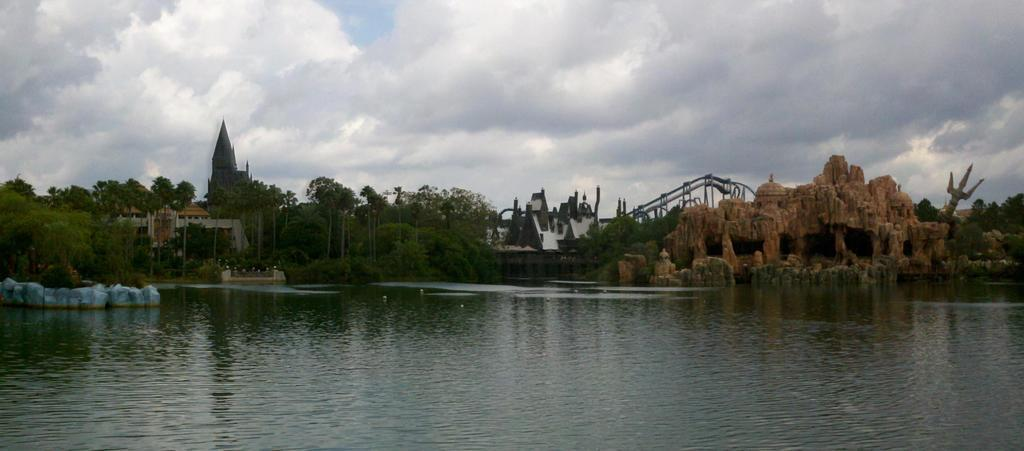What is visible in the sky in the image? The sky with clouds is visible in the image. What type of vegetation can be seen in the image? There are trees in the image. What type of structures are present in the image? There are castles in the image. What type of natural features can be seen in the image? There are rocks in the image. What else is visible in the image besides the sky, trees, castles, and rocks? There is water visible in the image. Can you see a surprise party happening in the image? There is no indication of a surprise party happening in the image. How many frogs can be seen hopping around in the image? There are no frogs present in the image. What type of writing instrument is visible in the image? There is no pen or any other writing instrument visible in the image. 